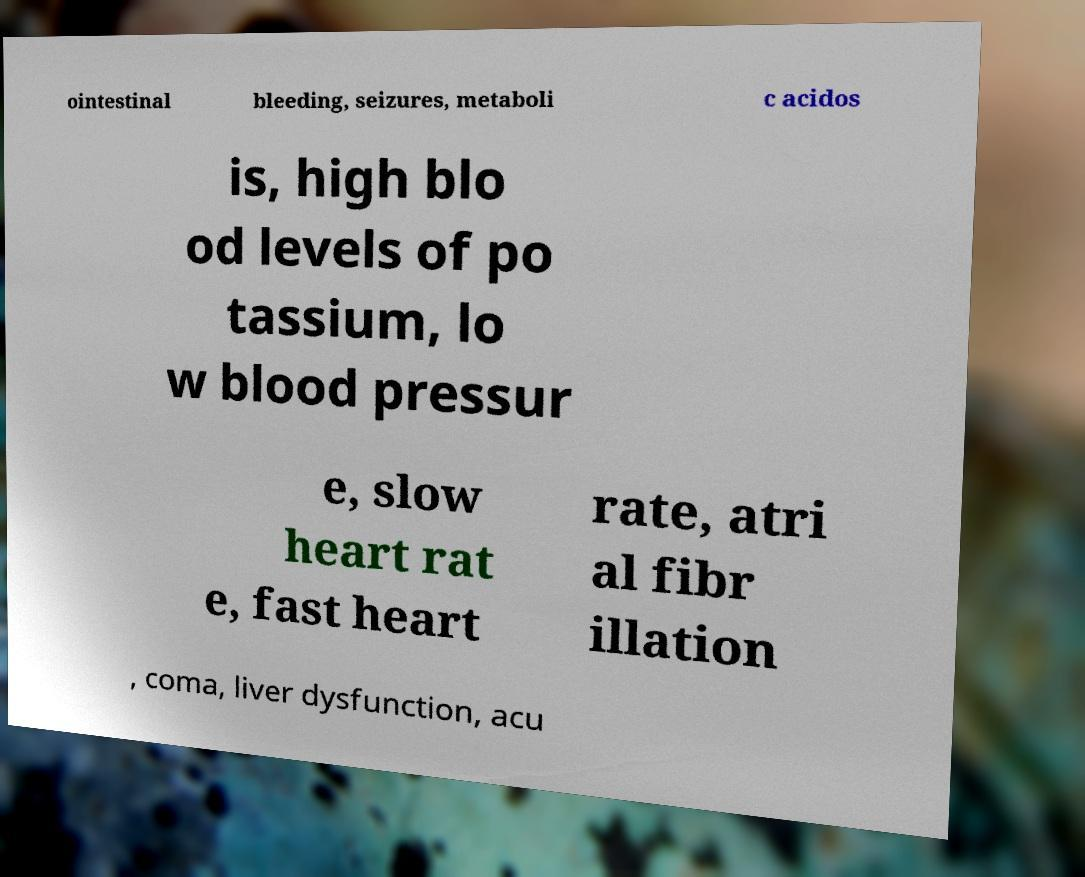Could you assist in decoding the text presented in this image and type it out clearly? ointestinal bleeding, seizures, metaboli c acidos is, high blo od levels of po tassium, lo w blood pressur e, slow heart rat e, fast heart rate, atri al fibr illation , coma, liver dysfunction, acu 